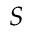Convert formula to latex. <formula><loc_0><loc_0><loc_500><loc_500>S</formula> 